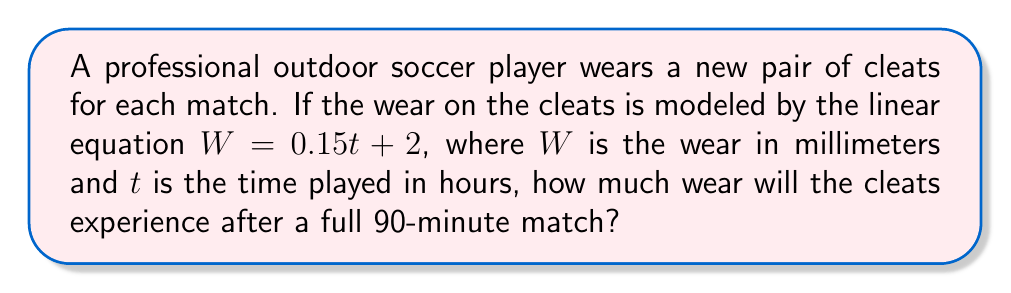Show me your answer to this math problem. To solve this problem, we'll follow these steps:

1) First, we need to convert the match duration from minutes to hours:
   90 minutes = 1.5 hours

2) Now, we can use the given linear equation:
   $W = 0.15t + 2$
   Where:
   $W$ = wear in millimeters
   $t$ = time played in hours
   
3) Substitute $t = 1.5$ into the equation:
   $W = 0.15(1.5) + 2$

4) Solve the equation:
   $W = 0.225 + 2$
   $W = 2.225$

5) Round to two decimal places:
   $W ≈ 2.23$ mm

Therefore, after a full 90-minute match, the cleats will experience approximately 2.23 mm of wear.
Answer: 2.23 mm 